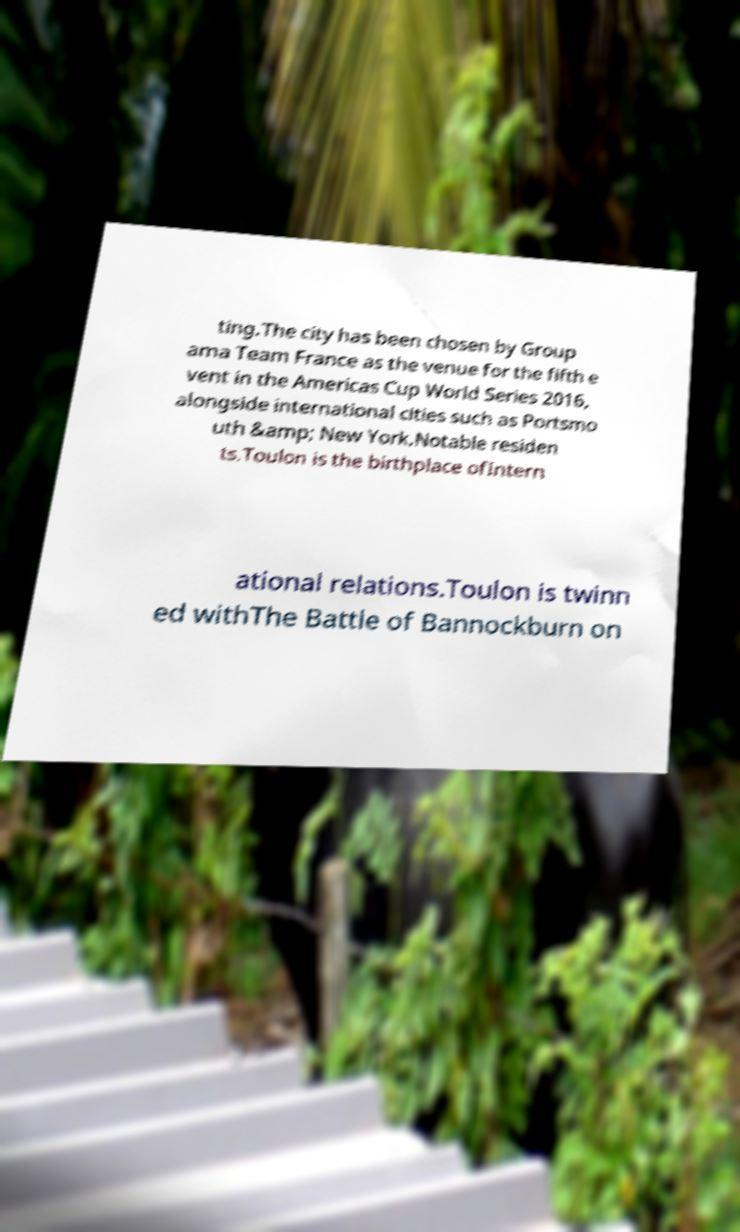Please read and relay the text visible in this image. What does it say? ting.The city has been chosen by Group ama Team France as the venue for the fifth e vent in the Americas Cup World Series 2016, alongside international cities such as Portsmo uth &amp; New York.Notable residen ts.Toulon is the birthplace ofIntern ational relations.Toulon is twinn ed withThe Battle of Bannockburn on 